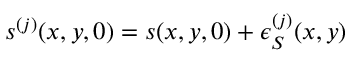Convert formula to latex. <formula><loc_0><loc_0><loc_500><loc_500>s ^ { ( j ) } ( x , y , 0 ) = s ( x , y , 0 ) + \epsilon _ { S } ^ { ( j ) } ( x , y )</formula> 